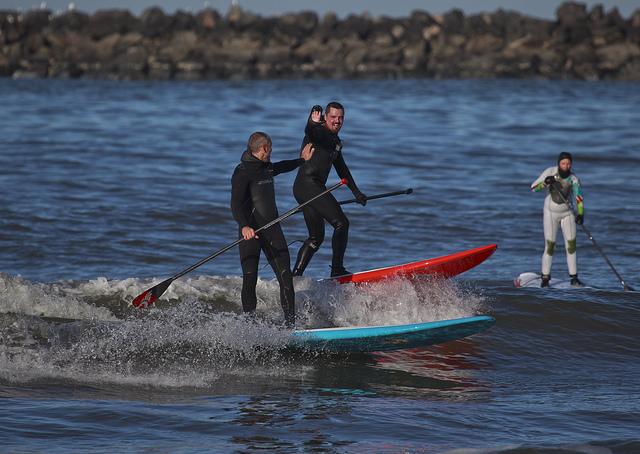What colors are the two paddle boards of the men in the black wetsuits?
Write a very short answer. Blue and red. Does everyone's outfits match?
Give a very brief answer. No. How many people are on the water?
Short answer required. 3. Is the couple young?
Concise answer only. Yes. 